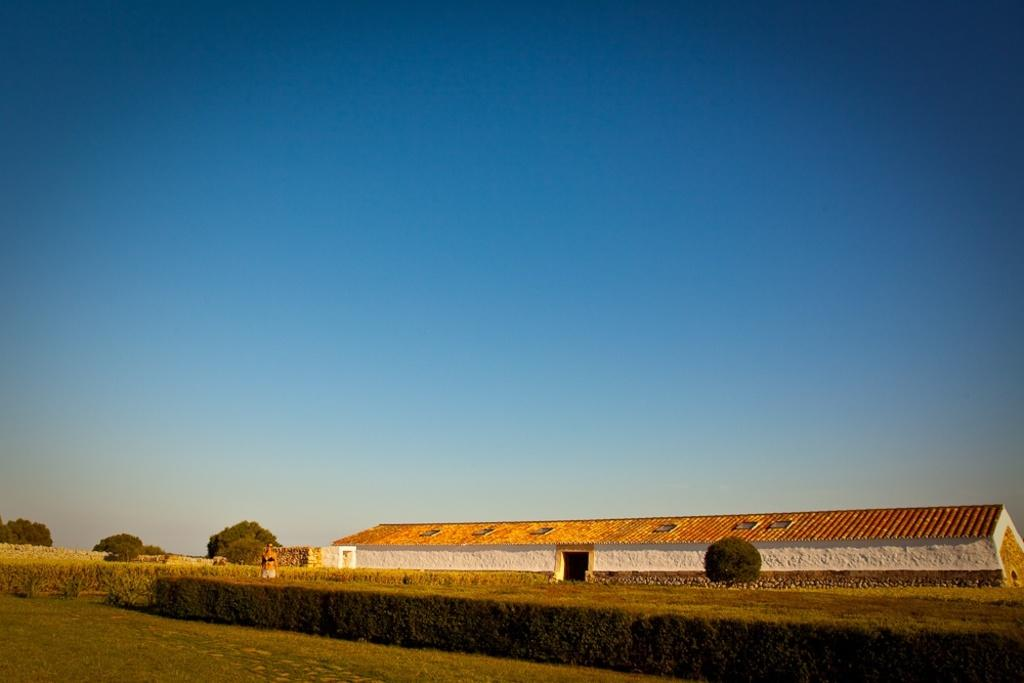What structure is located on the right side of the image? There is a building with a door on the right side of the image. What type of vegetation is near the building? There is a tree near the building. What type of vegetation is in front of the building? There are bushes in front of the building. What can be seen in the background of the image? There are trees and the sky visible in the background of the image. How many geese are walking on the roof of the building in the image? There are no geese present in the image, and therefore no such activity can be observed. What is the purpose of the building in the image? The purpose of the building cannot be determined from the image alone. 